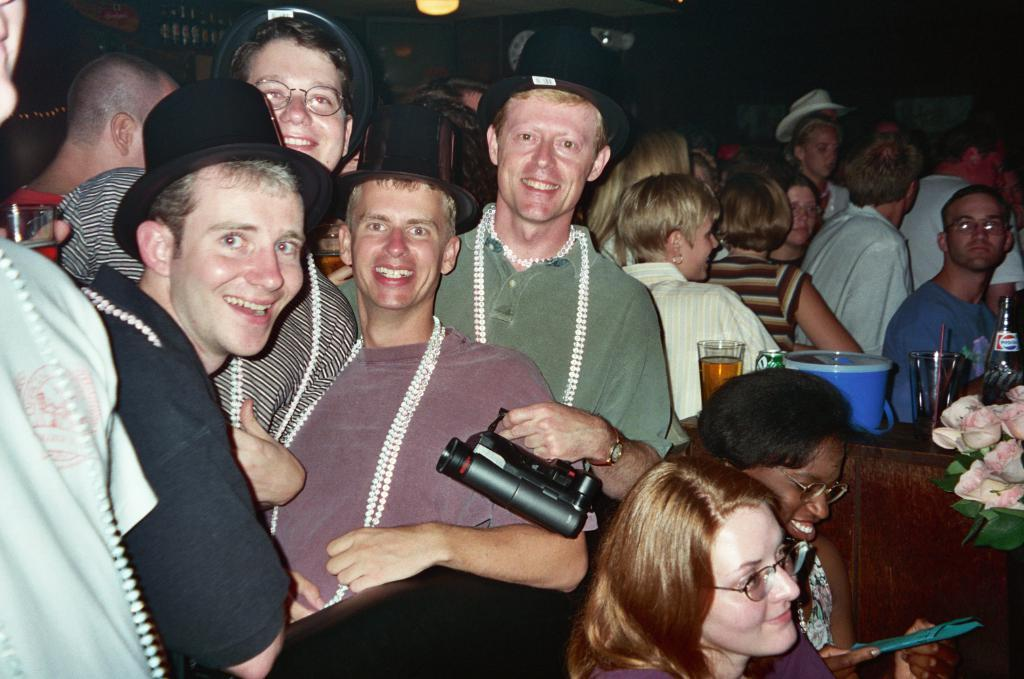How many people are in the image? There is a group of people in the image. What is present on the table in the image? There is a glass, a tube, and a flower vase on the table. What might be used for drinking in the image? The glass on the table might be used for drinking. What is the purpose of the tube on the table? The purpose of the tube on the table is not specified in the facts provided. What type of lipstick is the doll wearing in the image? There is no doll present in the image, so it is not possible to determine what type of lipstick the doll might be wearing. 